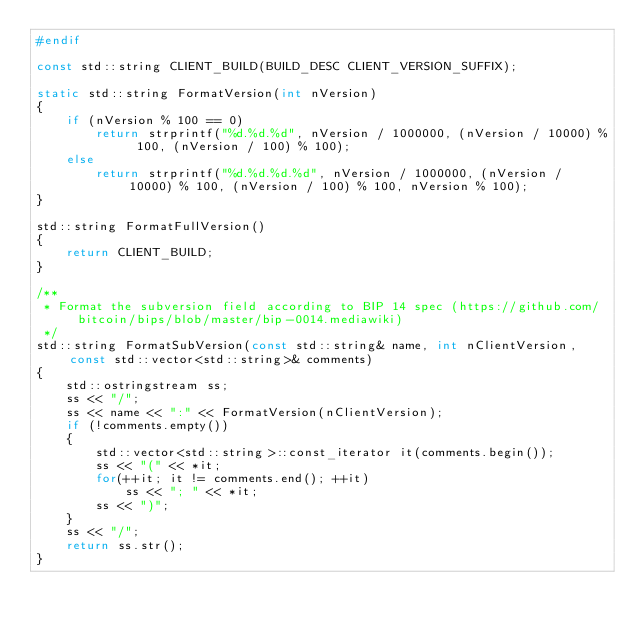Convert code to text. <code><loc_0><loc_0><loc_500><loc_500><_C++_>#endif

const std::string CLIENT_BUILD(BUILD_DESC CLIENT_VERSION_SUFFIX);

static std::string FormatVersion(int nVersion)
{
    if (nVersion % 100 == 0)
        return strprintf("%d.%d.%d", nVersion / 1000000, (nVersion / 10000) % 100, (nVersion / 100) % 100);
    else
        return strprintf("%d.%d.%d.%d", nVersion / 1000000, (nVersion / 10000) % 100, (nVersion / 100) % 100, nVersion % 100);
}

std::string FormatFullVersion()
{
    return CLIENT_BUILD;
}

/**
 * Format the subversion field according to BIP 14 spec (https://github.com/bitcoin/bips/blob/master/bip-0014.mediawiki)
 */
std::string FormatSubVersion(const std::string& name, int nClientVersion, const std::vector<std::string>& comments)
{
    std::ostringstream ss;
    ss << "/";
    ss << name << ":" << FormatVersion(nClientVersion);
    if (!comments.empty())
    {
        std::vector<std::string>::const_iterator it(comments.begin());
        ss << "(" << *it;
        for(++it; it != comments.end(); ++it)
            ss << "; " << *it;
        ss << ")";
    }
    ss << "/";
    return ss.str();
}
</code> 